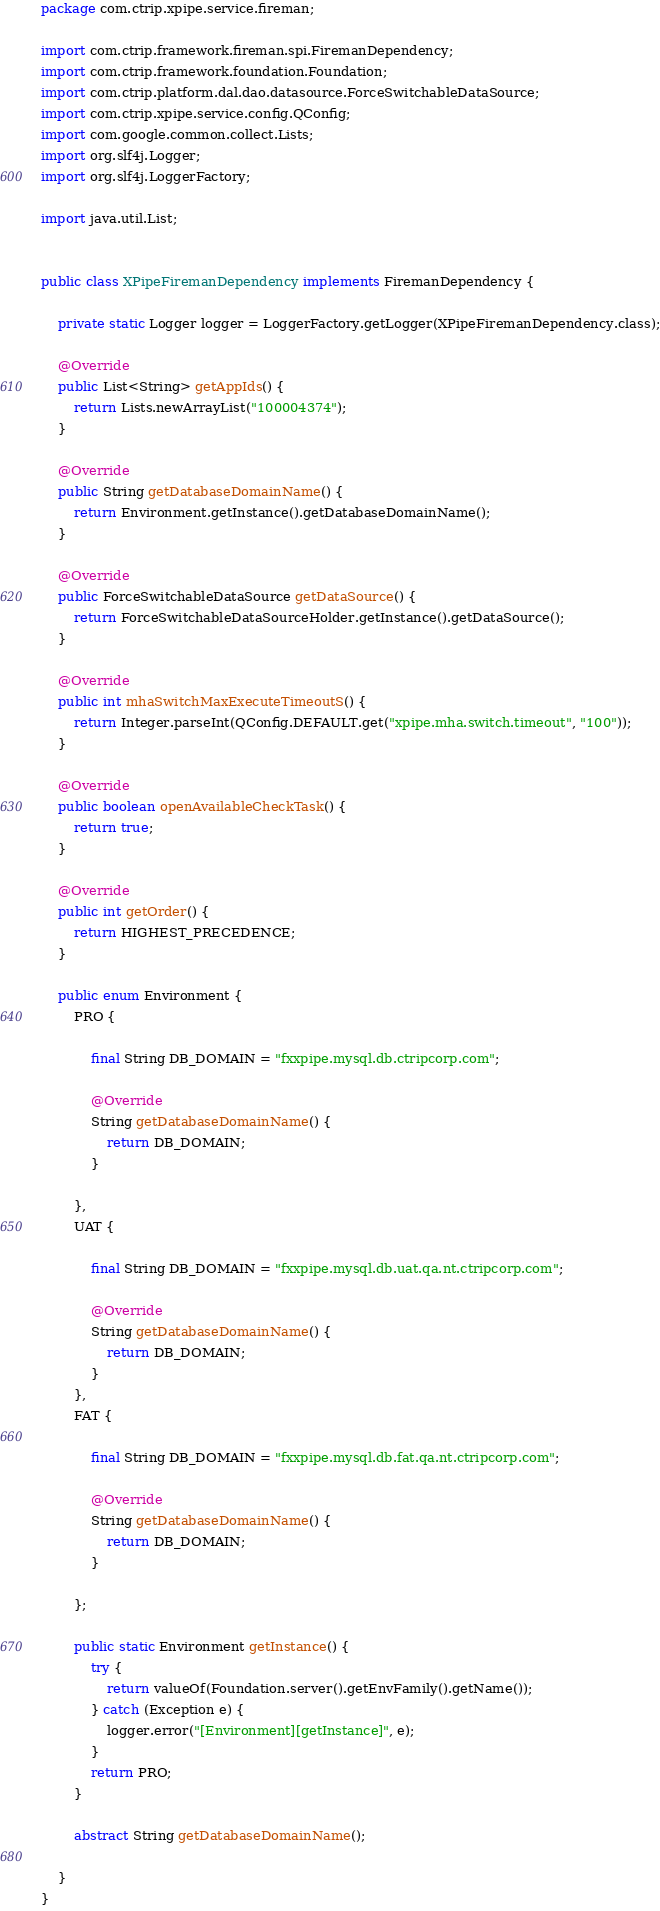<code> <loc_0><loc_0><loc_500><loc_500><_Java_>package com.ctrip.xpipe.service.fireman;

import com.ctrip.framework.fireman.spi.FiremanDependency;
import com.ctrip.framework.foundation.Foundation;
import com.ctrip.platform.dal.dao.datasource.ForceSwitchableDataSource;
import com.ctrip.xpipe.service.config.QConfig;
import com.google.common.collect.Lists;
import org.slf4j.Logger;
import org.slf4j.LoggerFactory;

import java.util.List;


public class XPipeFiremanDependency implements FiremanDependency {

    private static Logger logger = LoggerFactory.getLogger(XPipeFiremanDependency.class);

    @Override
    public List<String> getAppIds() {
        return Lists.newArrayList("100004374");
    }

    @Override
    public String getDatabaseDomainName() {
        return Environment.getInstance().getDatabaseDomainName();
    }

    @Override
    public ForceSwitchableDataSource getDataSource() {
        return ForceSwitchableDataSourceHolder.getInstance().getDataSource();
    }

    @Override
    public int mhaSwitchMaxExecuteTimeoutS() {
        return Integer.parseInt(QConfig.DEFAULT.get("xpipe.mha.switch.timeout", "100"));
    }

    @Override
    public boolean openAvailableCheckTask() {
        return true;
    }

    @Override
    public int getOrder() {
        return HIGHEST_PRECEDENCE;
    }

    public enum Environment {
        PRO {

            final String DB_DOMAIN = "fxxpipe.mysql.db.ctripcorp.com";

            @Override
            String getDatabaseDomainName() {
                return DB_DOMAIN;
            }

        },
        UAT {

            final String DB_DOMAIN = "fxxpipe.mysql.db.uat.qa.nt.ctripcorp.com";

            @Override
            String getDatabaseDomainName() {
                return DB_DOMAIN;
            }
        },
        FAT {

            final String DB_DOMAIN = "fxxpipe.mysql.db.fat.qa.nt.ctripcorp.com";

            @Override
            String getDatabaseDomainName() {
                return DB_DOMAIN;
            }

        };

        public static Environment getInstance() {
            try {
                return valueOf(Foundation.server().getEnvFamily().getName());
            } catch (Exception e) {
                logger.error("[Environment][getInstance]", e);
            }
            return PRO;
        }

        abstract String getDatabaseDomainName();

    }
}
</code> 